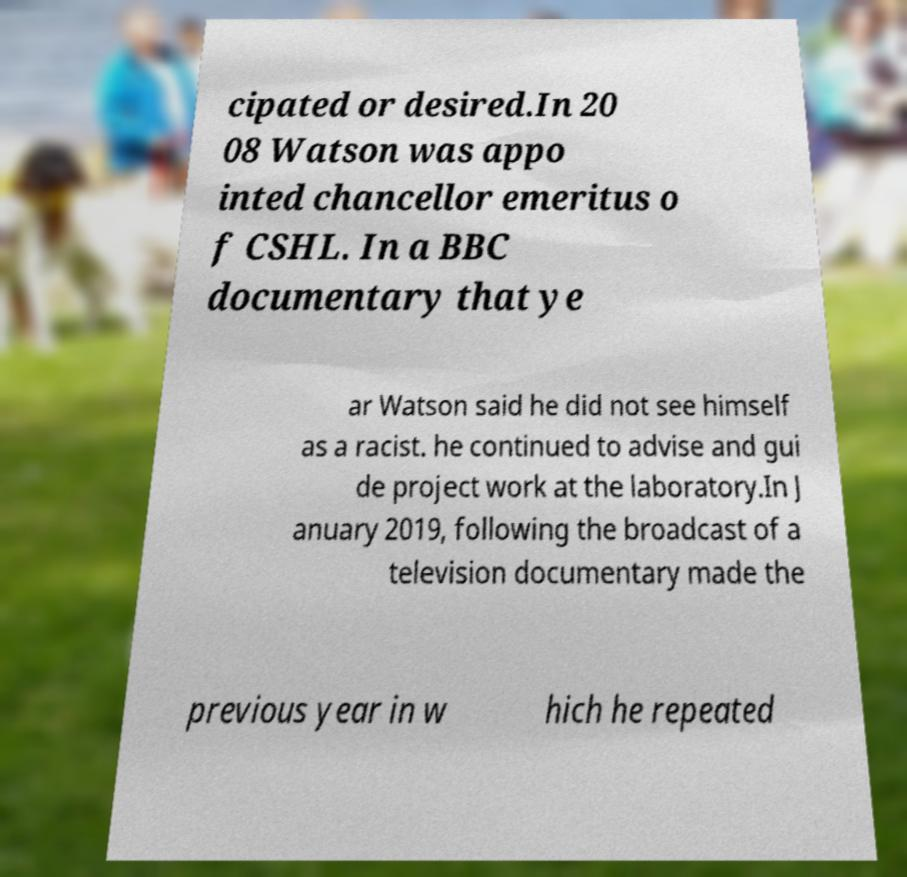Please read and relay the text visible in this image. What does it say? cipated or desired.In 20 08 Watson was appo inted chancellor emeritus o f CSHL. In a BBC documentary that ye ar Watson said he did not see himself as a racist. he continued to advise and gui de project work at the laboratory.In J anuary 2019, following the broadcast of a television documentary made the previous year in w hich he repeated 